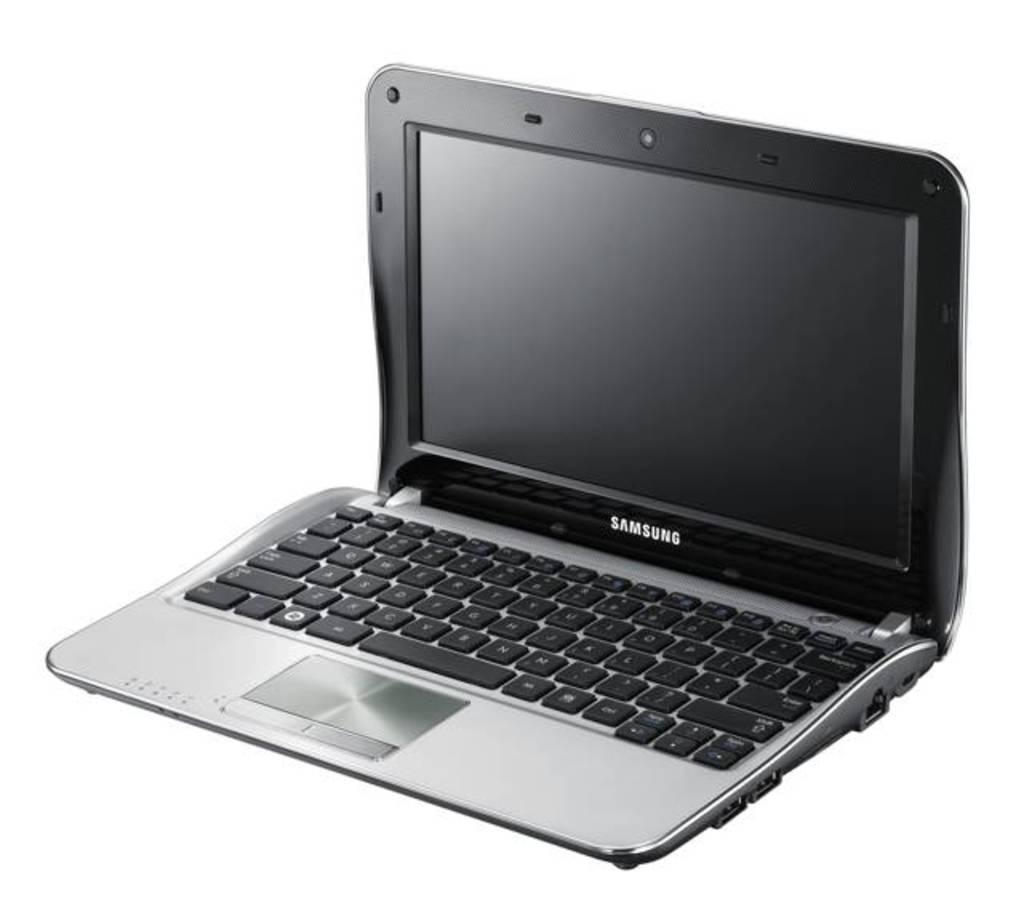<image>
Provide a brief description of the given image. A Samsung laptop computer with silver and black coloring and a shiny touchpad. 